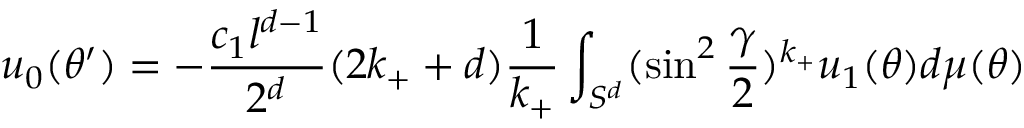<formula> <loc_0><loc_0><loc_500><loc_500>u _ { 0 } ( \theta ^ { \prime } ) = - { \frac { c _ { 1 } l ^ { d - 1 } } { 2 ^ { d } } } ( 2 k _ { + } + d ) { \frac { 1 } { k _ { + } } } \int _ { S ^ { d } } ( \sin ^ { 2 } { \frac { \gamma } { 2 } } ) ^ { k _ { + } } u _ { 1 } ( \theta ) d \mu ( \theta )</formula> 